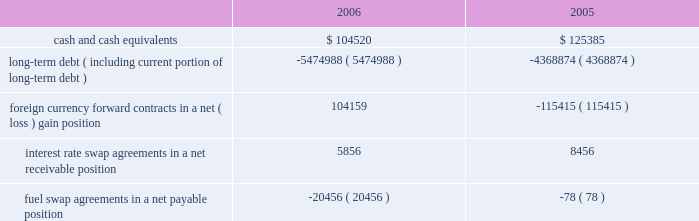Note 9 .
Retirement plan we maintain a defined contribution pension plan covering full-time shoreside employees who have completed the minimum period of continuous service .
Annual contributions to the plan are based on fixed percentages of participants 2019 salaries and years of service , not to exceed certain maximums .
Pension cost was $ 13.9 million , $ 12.8 million and $ 12.2 million for the years ended december 31 , 2006 , 2005 and 2004 , respectively .
Note 10 .
Income taxes we and the majority of our subsidiaries are currently exempt from united states corporate tax on income from the international opera- tion of ships pursuant to section 883 of the internal revenue code .
Income tax expense related to our remaining subsidiaries was not significant for the years ended december 31 , 2006 , 2005 and 2004 .
Final regulations under section 883 were published on august 26 , 2003 , and were effective for the year ended december 31 , 2005 .
These regulations confirmed that we qualify for the exemption provid- ed by section 883 , but also narrowed the scope of activities which are considered by the internal revenue service to be incidental to the international operation of ships .
The activities listed in the regula- tions as not being incidental to the international operation of ships include income from the sale of air and other transportation such as transfers , shore excursions and pre and post cruise tours .
To the extent the income from such activities is earned from sources within the united states , such income will be subject to united states taxa- tion .
The application of these new regulations reduced our net income for the years ended december 31 , 2006 and december 31 , 2005 by approximately $ 6.3 million and $ 14.0 million , respectively .
Note 11 .
Financial instruments the estimated fair values of our financial instruments are as follows ( in thousands ) : .
Long-term debt ( including current portion of long-term debt ) ( 5474988 ) ( 4368874 ) foreign currency forward contracts in a net ( loss ) gain position 104159 ( 115415 ) interest rate swap agreements in a net receivable position 5856 8456 fuel swap agreements in a net payable position ( 20456 ) ( 78 ) the reported fair values are based on a variety of factors and assumptions .
Accordingly , the fair values may not represent actual values of the financial instruments that could have been realized as of december 31 , 2006 or 2005 , or that will be realized in the future and do not include expenses that could be incurred in an actual sale or settlement .
Our financial instruments are not held for trading or speculative purposes .
Our exposure under foreign currency contracts , interest rate and fuel swap agreements is limited to the cost of replacing the contracts in the event of non-performance by the counterparties to the contracts , all of which are currently our lending banks .
To minimize this risk , we select counterparties with credit risks acceptable to us and we limit our exposure to an individual counterparty .
Furthermore , all foreign currency forward contracts are denominated in primary currencies .
Cash and cash equivalents the carrying amounts of cash and cash equivalents approximate their fair values due to the short maturity of these instruments .
Long-term debt the fair values of our senior notes and senior debentures were esti- mated by obtaining quoted market prices .
The fair values of all other debt were estimated using discounted cash flow analyses based on market rates available to us for similar debt with the same remaining maturities .
Foreign currency contracts the fair values of our foreign currency forward contracts were esti- mated using current market prices for similar instruments .
Our expo- sure to market risk for fluctuations in foreign currency exchange rates relates to six ship construction contracts and forecasted transactions .
We use foreign currency forward contracts to mitigate the impact of fluctuations in foreign currency exchange rates .
As of december 31 , 2006 , we had foreign currency forward contracts in a notional amount of $ 3.8 billion maturing through 2009 .
As of december 31 , 2006 , the fair value of our foreign currency forward contracts related to the six ship construction contracts , which are designated as fair value hedges , was a net unrealized gain of approximately $ 106.3 mil- lion .
At december 31 , 2005 , the fair value of our foreign currency for- ward contracts related to three ship construction contracts , designated as fair value hedges , was a net unrealized loss of approx- imately $ 103.4 million .
The fair value of our foreign currency forward contracts related to the other ship construction contract at december 31 , 2005 , which was designated as a cash flow hedge , was an unre- alized loss , of approximately $ 7.8 million .
At december 31 , 2006 , approximately 11% ( 11 % ) of the aggregate cost of the ships was exposed to fluctuations in the euro exchange rate .
R o y a l c a r i b b e a n c r u i s e s l t d .
3 5 notes to the consolidated financial statements ( continued ) 51392_financials-v9.qxp 6/7/07 3:40 pm page 35 .
What was the total pension cost , in millions , from 2004-2006? 
Computations: ((13.9 + 12.8) + 12.2)
Answer: 38.9. 